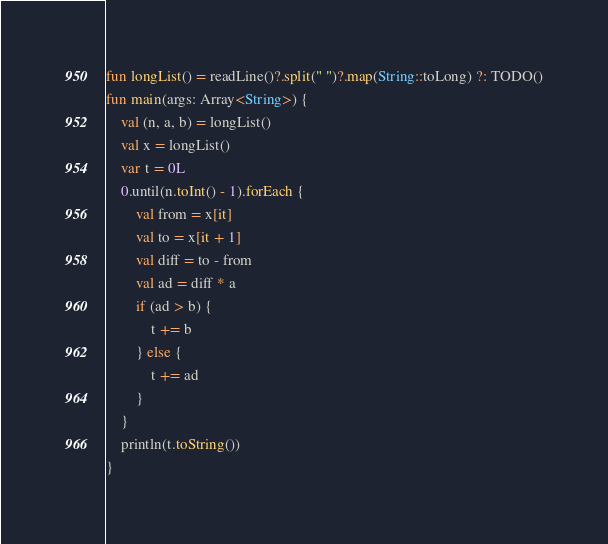Convert code to text. <code><loc_0><loc_0><loc_500><loc_500><_Kotlin_>fun longList() = readLine()?.split(" ")?.map(String::toLong) ?: TODO()
fun main(args: Array<String>) {
    val (n, a, b) = longList()
    val x = longList()
    var t = 0L
    0.until(n.toInt() - 1).forEach {
        val from = x[it]
        val to = x[it + 1]
        val diff = to - from
        val ad = diff * a
        if (ad > b) {
            t += b
        } else {
            t += ad
        }
    }
    println(t.toString())
}
</code> 